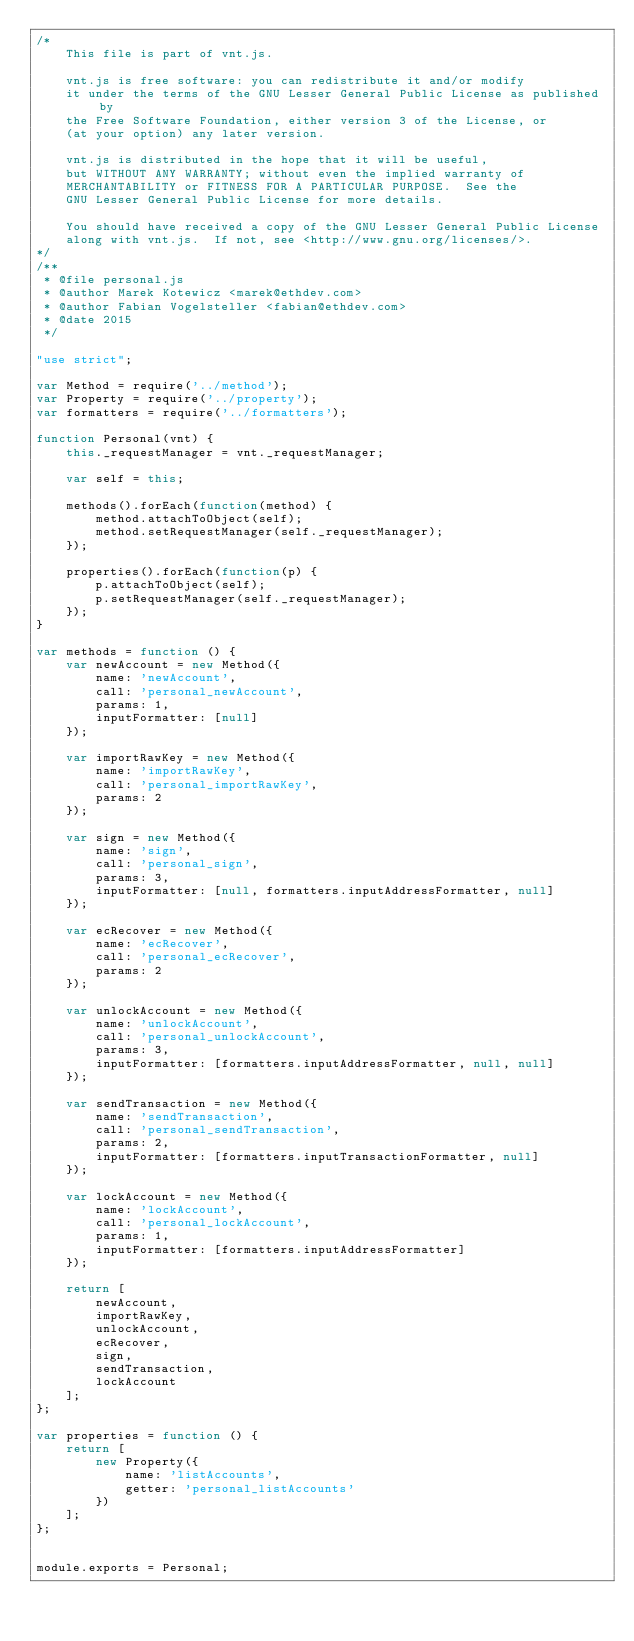Convert code to text. <code><loc_0><loc_0><loc_500><loc_500><_JavaScript_>/*
    This file is part of vnt.js.

    vnt.js is free software: you can redistribute it and/or modify
    it under the terms of the GNU Lesser General Public License as published by
    the Free Software Foundation, either version 3 of the License, or
    (at your option) any later version.

    vnt.js is distributed in the hope that it will be useful,
    but WITHOUT ANY WARRANTY; without even the implied warranty of
    MERCHANTABILITY or FITNESS FOR A PARTICULAR PURPOSE.  See the
    GNU Lesser General Public License for more details.

    You should have received a copy of the GNU Lesser General Public License
    along with vnt.js.  If not, see <http://www.gnu.org/licenses/>.
*/
/**
 * @file personal.js
 * @author Marek Kotewicz <marek@ethdev.com>
 * @author Fabian Vogelsteller <fabian@ethdev.com>
 * @date 2015
 */

"use strict";

var Method = require('../method');
var Property = require('../property');
var formatters = require('../formatters');

function Personal(vnt) {
    this._requestManager = vnt._requestManager;

    var self = this;

    methods().forEach(function(method) {
        method.attachToObject(self);
        method.setRequestManager(self._requestManager);
    });

    properties().forEach(function(p) {
        p.attachToObject(self);
        p.setRequestManager(self._requestManager);
    });
}

var methods = function () {
    var newAccount = new Method({
        name: 'newAccount',
        call: 'personal_newAccount',
        params: 1,
        inputFormatter: [null]
    });

    var importRawKey = new Method({
        name: 'importRawKey',
		call: 'personal_importRawKey',
		params: 2
    });

    var sign = new Method({
        name: 'sign',
		call: 'personal_sign',
		params: 3,
		inputFormatter: [null, formatters.inputAddressFormatter, null]
    });

    var ecRecover = new Method({
        name: 'ecRecover',
		call: 'personal_ecRecover',
		params: 2
    });

    var unlockAccount = new Method({
        name: 'unlockAccount',
        call: 'personal_unlockAccount',
        params: 3,
        inputFormatter: [formatters.inputAddressFormatter, null, null]
    });

    var sendTransaction = new Method({
        name: 'sendTransaction',
        call: 'personal_sendTransaction',
        params: 2,
        inputFormatter: [formatters.inputTransactionFormatter, null]
    });

    var lockAccount = new Method({
        name: 'lockAccount',
        call: 'personal_lockAccount',
        params: 1,
        inputFormatter: [formatters.inputAddressFormatter]
    });

    return [
        newAccount,
        importRawKey,
        unlockAccount,
        ecRecover,
        sign,
        sendTransaction,
        lockAccount
    ];
};

var properties = function () {
    return [
        new Property({
            name: 'listAccounts',
            getter: 'personal_listAccounts'
        })
    ];
};


module.exports = Personal;
</code> 